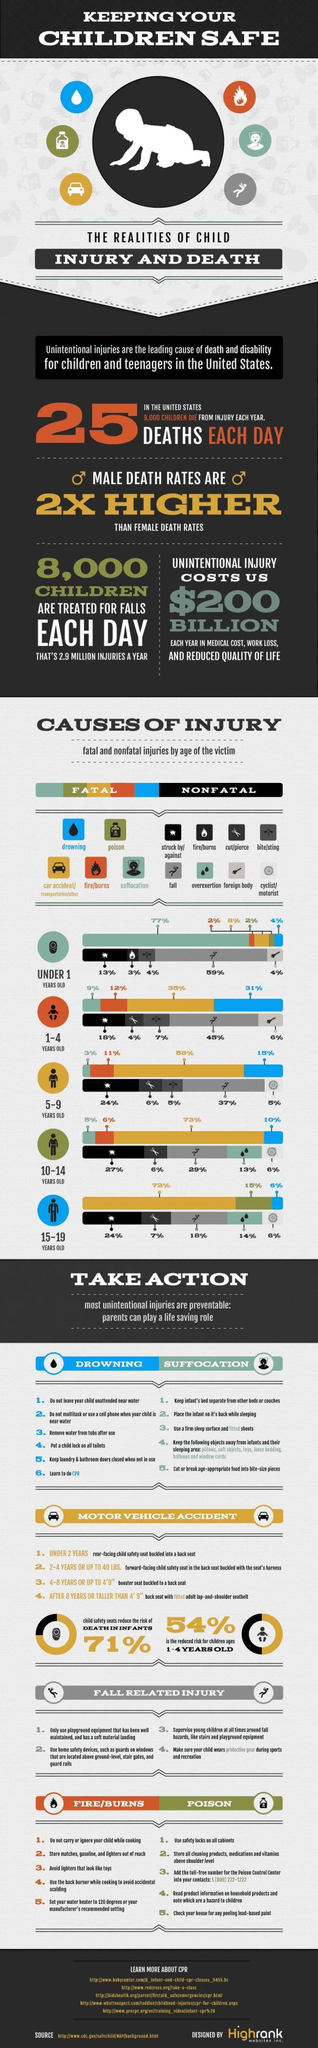What percent of children aged 5-9 years old in the U.S. were injured by falls?
Answer the question with a short phrase. 37% What is the major cause of fatal injuries for children aged under 1 year old in the U.S.? suffocation What percent of children aged 15-19 years old in the U.S. were injured by overexertion? 14% What is the major cause of nonfatal injuries for children aged 1-4 years old in the U.S.? fall What percent of children under 1 year old were killed due to poisoning in the U.S.? 2% What percent of children aged 1-4 years old were killed by drowning in the U.S.? 31% What is the major cause of fatal injuries for children aged 15-19 years old in the U.S.? car accident/transportation/other What percent of children under 1 year old were killed by suffocation in the U.S.? 77% 